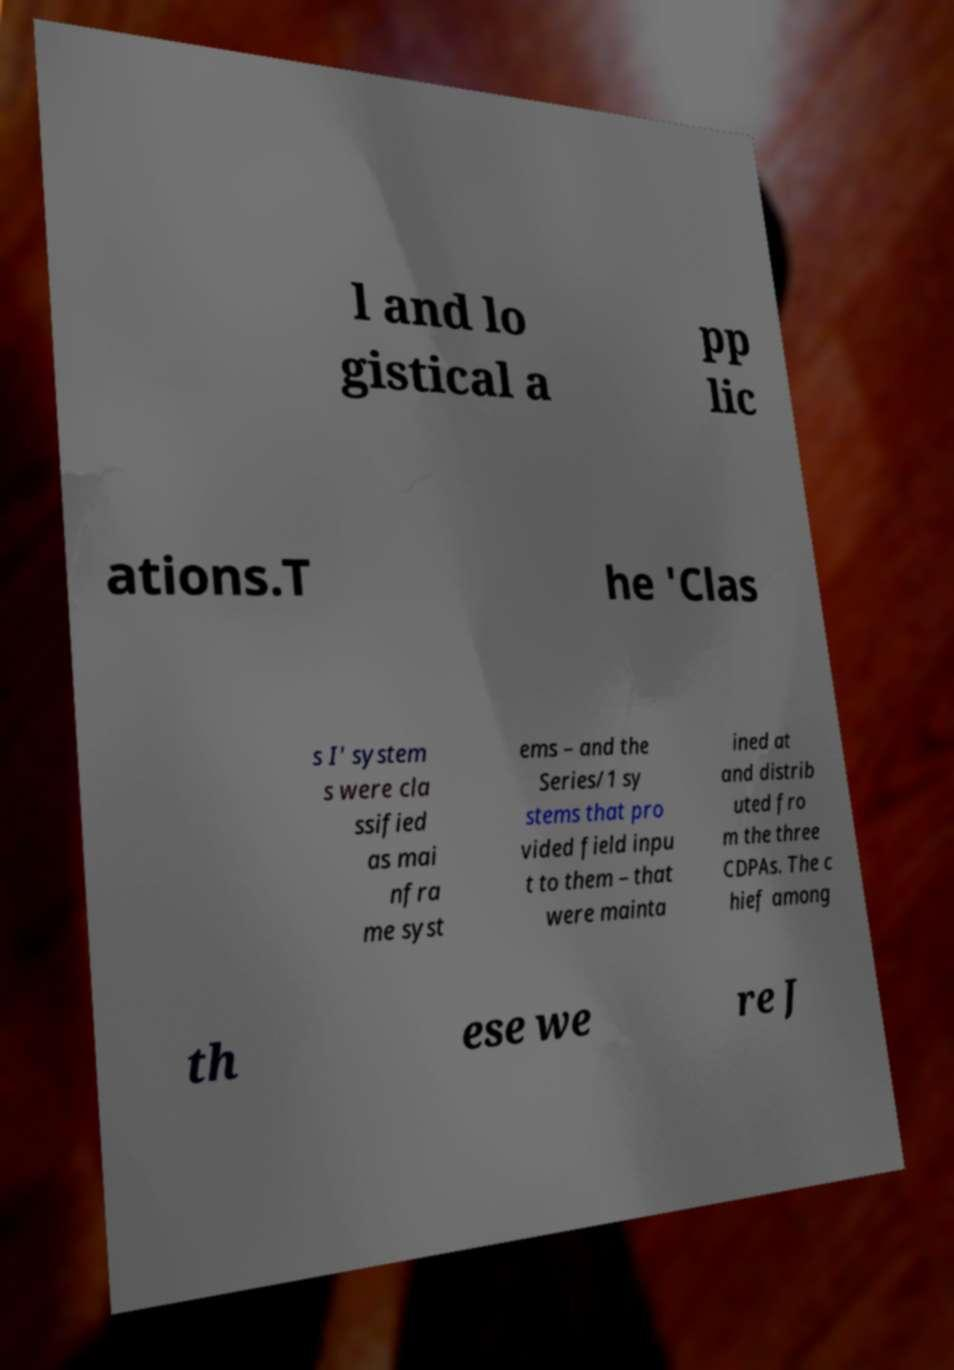Can you accurately transcribe the text from the provided image for me? l and lo gistical a pp lic ations.T he 'Clas s I' system s were cla ssified as mai nfra me syst ems – and the Series/1 sy stems that pro vided field inpu t to them – that were mainta ined at and distrib uted fro m the three CDPAs. The c hief among th ese we re J 